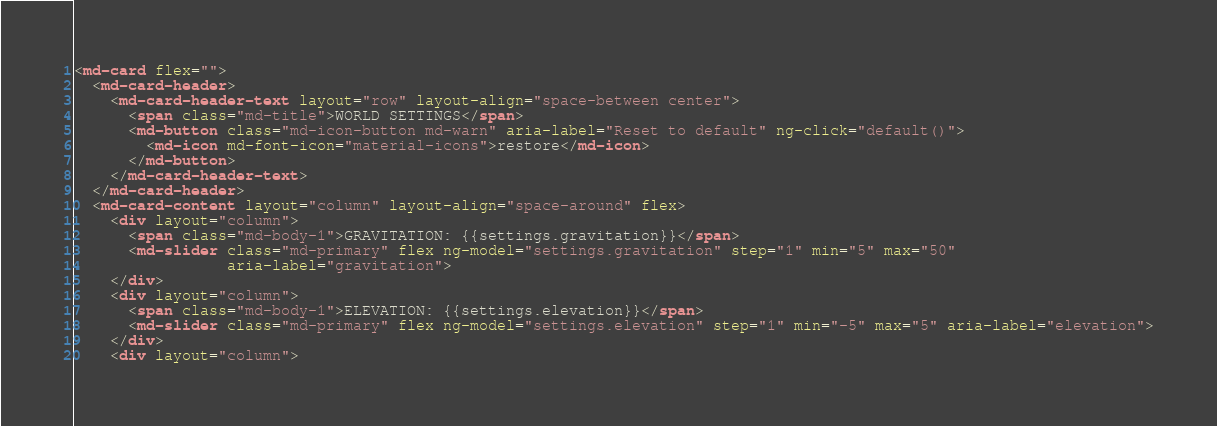Convert code to text. <code><loc_0><loc_0><loc_500><loc_500><_HTML_><md-card flex="">
  <md-card-header>
    <md-card-header-text layout="row" layout-align="space-between center">
      <span class="md-title">WORLD SETTINGS</span>
      <md-button class="md-icon-button md-warn" aria-label="Reset to default" ng-click="default()">
        <md-icon md-font-icon="material-icons">restore</md-icon>
      </md-button>
    </md-card-header-text>
  </md-card-header>
  <md-card-content layout="column" layout-align="space-around" flex>
    <div layout="column">
      <span class="md-body-1">GRAVITATION: {{settings.gravitation}}</span>
      <md-slider class="md-primary" flex ng-model="settings.gravitation" step="1" min="5" max="50"
                 aria-label="gravitation">
    </div>
    <div layout="column">
      <span class="md-body-1">ELEVATION: {{settings.elevation}}</span>
      <md-slider class="md-primary" flex ng-model="settings.elevation" step="1" min="-5" max="5" aria-label="elevation">
    </div>
    <div layout="column"></code> 